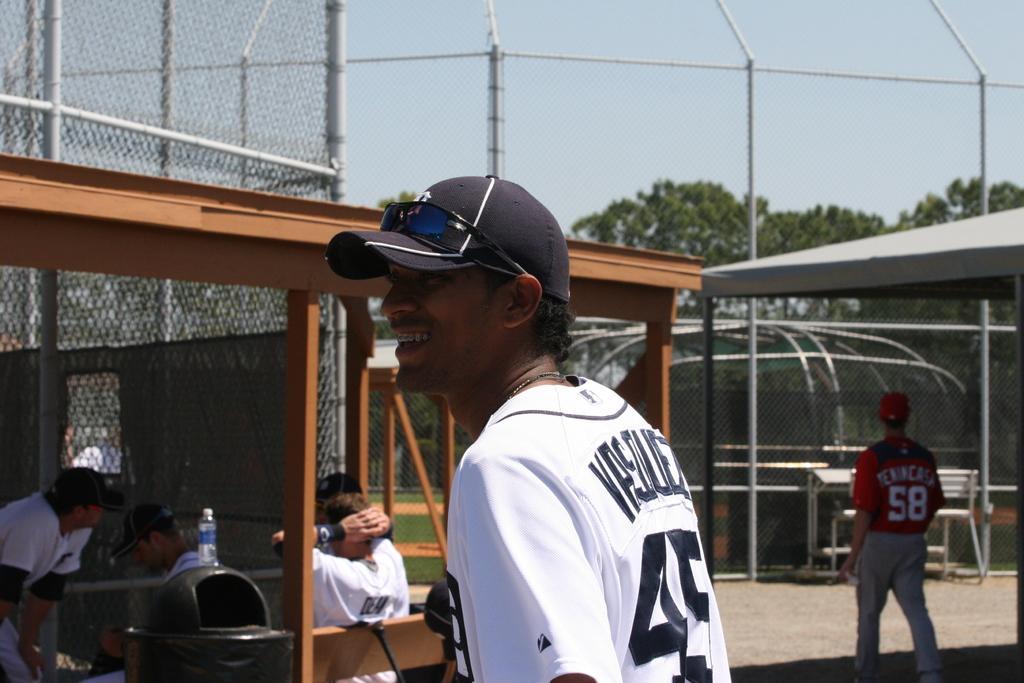Describe this image in one or two sentences. In the picture I can see people among them some are standing on the ground and some are sitting. I can also see fence, poles, a bottle on an object and some other objects on the ground. In the background I can see the sky and trees. 